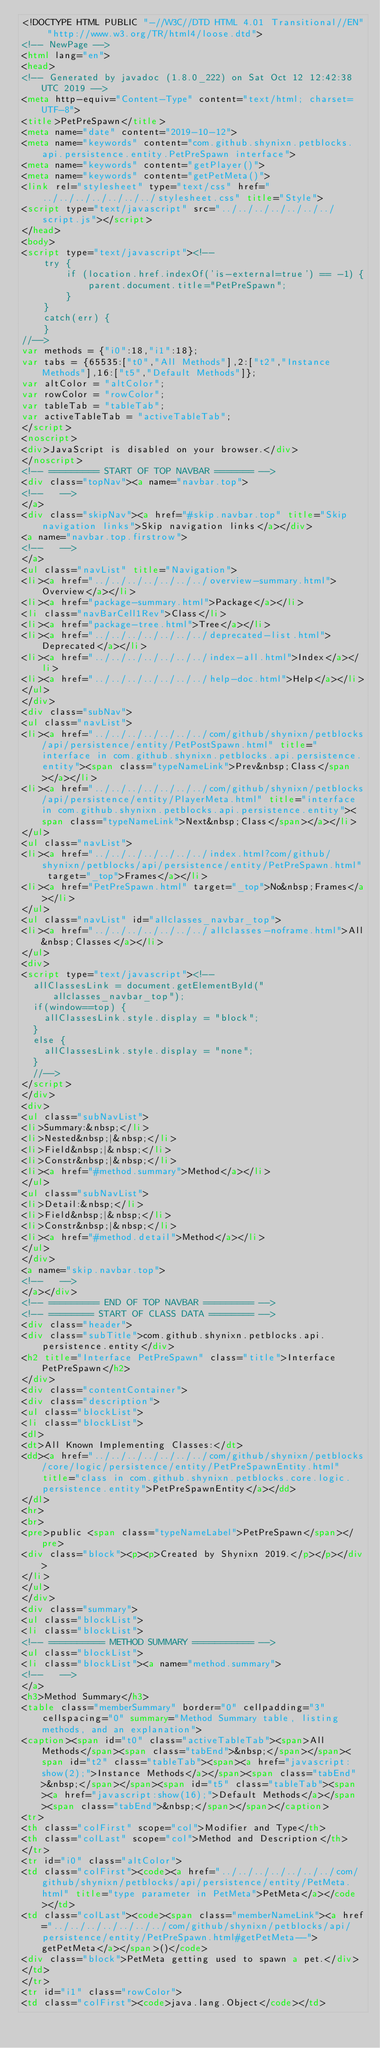<code> <loc_0><loc_0><loc_500><loc_500><_HTML_><!DOCTYPE HTML PUBLIC "-//W3C//DTD HTML 4.01 Transitional//EN" "http://www.w3.org/TR/html4/loose.dtd">
<!-- NewPage -->
<html lang="en">
<head>
<!-- Generated by javadoc (1.8.0_222) on Sat Oct 12 12:42:38 UTC 2019 -->
<meta http-equiv="Content-Type" content="text/html; charset=UTF-8">
<title>PetPreSpawn</title>
<meta name="date" content="2019-10-12">
<meta name="keywords" content="com.github.shynixn.petblocks.api.persistence.entity.PetPreSpawn interface">
<meta name="keywords" content="getPlayer()">
<meta name="keywords" content="getPetMeta()">
<link rel="stylesheet" type="text/css" href="../../../../../../../stylesheet.css" title="Style">
<script type="text/javascript" src="../../../../../../../script.js"></script>
</head>
<body>
<script type="text/javascript"><!--
    try {
        if (location.href.indexOf('is-external=true') == -1) {
            parent.document.title="PetPreSpawn";
        }
    }
    catch(err) {
    }
//-->
var methods = {"i0":18,"i1":18};
var tabs = {65535:["t0","All Methods"],2:["t2","Instance Methods"],16:["t5","Default Methods"]};
var altColor = "altColor";
var rowColor = "rowColor";
var tableTab = "tableTab";
var activeTableTab = "activeTableTab";
</script>
<noscript>
<div>JavaScript is disabled on your browser.</div>
</noscript>
<!-- ========= START OF TOP NAVBAR ======= -->
<div class="topNav"><a name="navbar.top">
<!--   -->
</a>
<div class="skipNav"><a href="#skip.navbar.top" title="Skip navigation links">Skip navigation links</a></div>
<a name="navbar.top.firstrow">
<!--   -->
</a>
<ul class="navList" title="Navigation">
<li><a href="../../../../../../../overview-summary.html">Overview</a></li>
<li><a href="package-summary.html">Package</a></li>
<li class="navBarCell1Rev">Class</li>
<li><a href="package-tree.html">Tree</a></li>
<li><a href="../../../../../../../deprecated-list.html">Deprecated</a></li>
<li><a href="../../../../../../../index-all.html">Index</a></li>
<li><a href="../../../../../../../help-doc.html">Help</a></li>
</ul>
</div>
<div class="subNav">
<ul class="navList">
<li><a href="../../../../../../../com/github/shynixn/petblocks/api/persistence/entity/PetPostSpawn.html" title="interface in com.github.shynixn.petblocks.api.persistence.entity"><span class="typeNameLink">Prev&nbsp;Class</span></a></li>
<li><a href="../../../../../../../com/github/shynixn/petblocks/api/persistence/entity/PlayerMeta.html" title="interface in com.github.shynixn.petblocks.api.persistence.entity"><span class="typeNameLink">Next&nbsp;Class</span></a></li>
</ul>
<ul class="navList">
<li><a href="../../../../../../../index.html?com/github/shynixn/petblocks/api/persistence/entity/PetPreSpawn.html" target="_top">Frames</a></li>
<li><a href="PetPreSpawn.html" target="_top">No&nbsp;Frames</a></li>
</ul>
<ul class="navList" id="allclasses_navbar_top">
<li><a href="../../../../../../../allclasses-noframe.html">All&nbsp;Classes</a></li>
</ul>
<div>
<script type="text/javascript"><!--
  allClassesLink = document.getElementById("allclasses_navbar_top");
  if(window==top) {
    allClassesLink.style.display = "block";
  }
  else {
    allClassesLink.style.display = "none";
  }
  //-->
</script>
</div>
<div>
<ul class="subNavList">
<li>Summary:&nbsp;</li>
<li>Nested&nbsp;|&nbsp;</li>
<li>Field&nbsp;|&nbsp;</li>
<li>Constr&nbsp;|&nbsp;</li>
<li><a href="#method.summary">Method</a></li>
</ul>
<ul class="subNavList">
<li>Detail:&nbsp;</li>
<li>Field&nbsp;|&nbsp;</li>
<li>Constr&nbsp;|&nbsp;</li>
<li><a href="#method.detail">Method</a></li>
</ul>
</div>
<a name="skip.navbar.top">
<!--   -->
</a></div>
<!-- ========= END OF TOP NAVBAR ========= -->
<!-- ======== START OF CLASS DATA ======== -->
<div class="header">
<div class="subTitle">com.github.shynixn.petblocks.api.persistence.entity</div>
<h2 title="Interface PetPreSpawn" class="title">Interface PetPreSpawn</h2>
</div>
<div class="contentContainer">
<div class="description">
<ul class="blockList">
<li class="blockList">
<dl>
<dt>All Known Implementing Classes:</dt>
<dd><a href="../../../../../../../com/github/shynixn/petblocks/core/logic/persistence/entity/PetPreSpawnEntity.html" title="class in com.github.shynixn.petblocks.core.logic.persistence.entity">PetPreSpawnEntity</a></dd>
</dl>
<hr>
<br>
<pre>public <span class="typeNameLabel">PetPreSpawn</span></pre>
<div class="block"><p><p>Created by Shynixn 2019.</p></p></div>
</li>
</ul>
</div>
<div class="summary">
<ul class="blockList">
<li class="blockList">
<!-- ========== METHOD SUMMARY =========== -->
<ul class="blockList">
<li class="blockList"><a name="method.summary">
<!--   -->
</a>
<h3>Method Summary</h3>
<table class="memberSummary" border="0" cellpadding="3" cellspacing="0" summary="Method Summary table, listing methods, and an explanation">
<caption><span id="t0" class="activeTableTab"><span>All Methods</span><span class="tabEnd">&nbsp;</span></span><span id="t2" class="tableTab"><span><a href="javascript:show(2);">Instance Methods</a></span><span class="tabEnd">&nbsp;</span></span><span id="t5" class="tableTab"><span><a href="javascript:show(16);">Default Methods</a></span><span class="tabEnd">&nbsp;</span></span></caption>
<tr>
<th class="colFirst" scope="col">Modifier and Type</th>
<th class="colLast" scope="col">Method and Description</th>
</tr>
<tr id="i0" class="altColor">
<td class="colFirst"><code><a href="../../../../../../../com/github/shynixn/petblocks/api/persistence/entity/PetMeta.html" title="type parameter in PetMeta">PetMeta</a></code></td>
<td class="colLast"><code><span class="memberNameLink"><a href="../../../../../../../com/github/shynixn/petblocks/api/persistence/entity/PetPreSpawn.html#getPetMeta--">getPetMeta</a></span>()</code>
<div class="block">PetMeta getting used to spawn a pet.</div>
</td>
</tr>
<tr id="i1" class="rowColor">
<td class="colFirst"><code>java.lang.Object</code></td></code> 